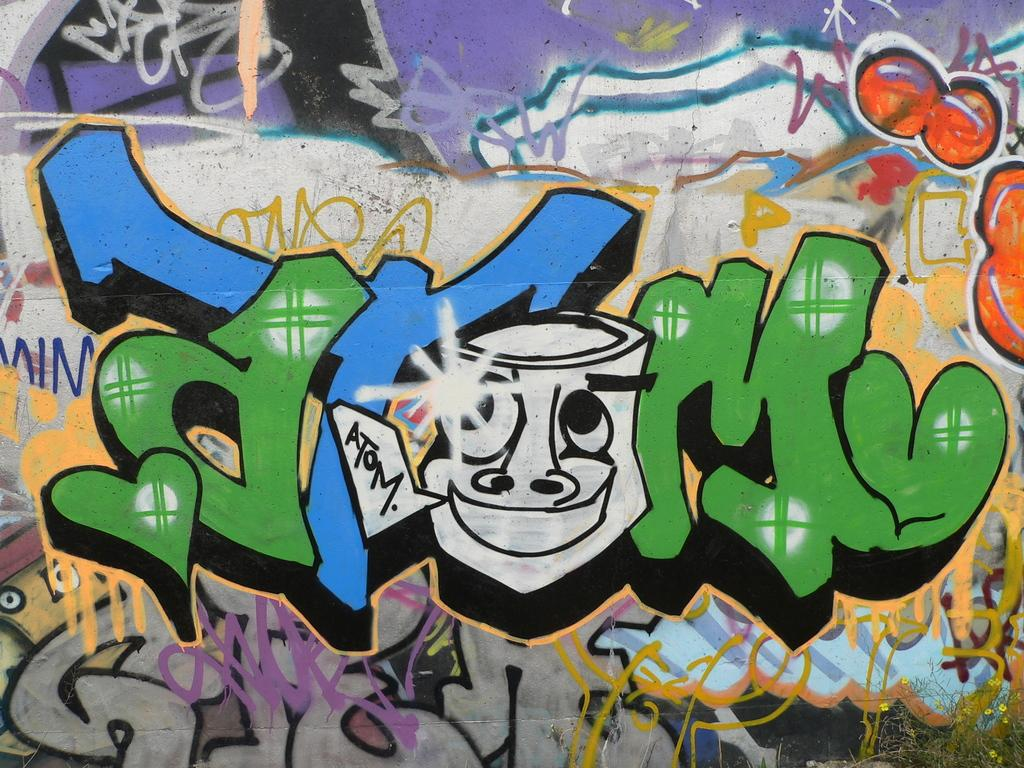What is depicted on the wall in the image? There is a wall painting in the image. What can be observed about the text or design on the wall painting? Something is written on the wall painting with different colors. What type of flowers are present in the image? There are yellow color flowers in the image. Can you describe the condition of the plant in the image? There is a dry plant in the image. What type of thunder can be heard in the image? There is no thunder present in the image, as it is a still image and not an audio recording. 